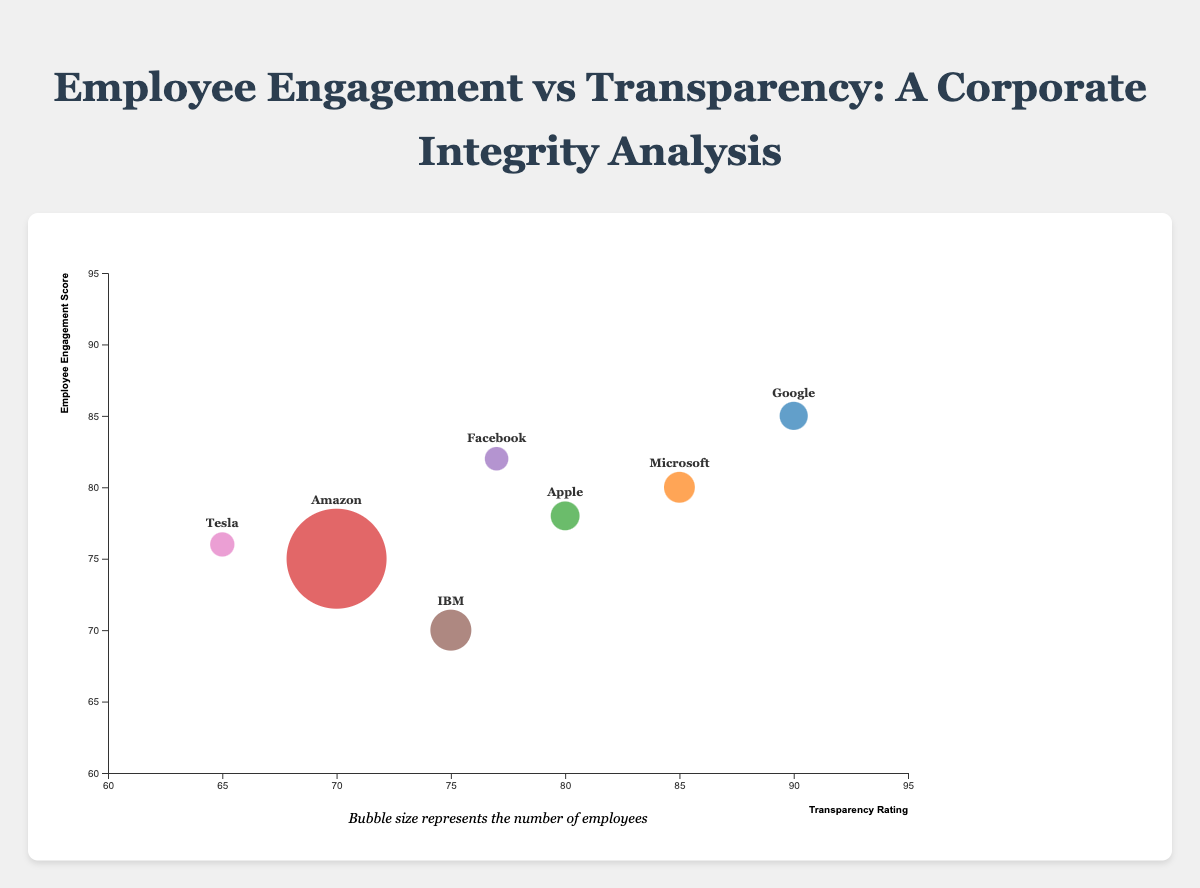What is the title of the Bubble Chart? The title is found at the top of the chart: "Employee Engagement vs Transparency: A Corporate Integrity Analysis." This text clearly describes the subject of the chart.
Answer: Employee Engagement vs Transparency: A Corporate Integrity Analysis How many firms are represented in this Bubble Chart? By counting the distinct bubbles on the chart and their corresponding labels, we can determine there are 7 firms included in the data.
Answer: 7 Which firm has the largest bubble in the chart, and what is its size representing? The largest bubble is for Amazon, as it visually stands out and is larger than others. The size of the bubble represents the number of employees, which for Amazon is 1,335,000.
Answer: Amazon (1,335,000 employees) Which firm has the highest employee engagement score, and what is the associated transparency rating? Google has the highest employee engagement score of 85. Looking at the coordinates, Google's transparency rating is 90.
Answer: Google (85 engagement, 90 transparency) What is the average transparency rating of all firms? Summing up the transparency ratings (90 + 85 + 80 + 70 + 77 + 75 + 65) gives 542. Dividing by the number of firms (7), we get an average transparency rating of 542/7 ≈ 77.43.
Answer: 77.43 Which firm in California has the highest employee engagement score? Three firms are located in California: Google, Apple, and Facebook. Google has the highest employee engagement score among them, which is 85.
Answer: Google Which firms have a transparency rating of at least 80? Looking at the x-axis, firms with a transparency rating of at least 80 include Google (90), Microsoft (85), Apple (80), and Facebook (77 is below the threshold).
Answer: Google, Microsoft, Apple What is the difference in employee engagement scores between the highest and lowest scoring firms? The highest engagement score is 85 (Google), and the lowest is 70 (IBM). The difference is 85 - 70 = 15.
Answer: 15 Which firm has the highest transparency rating but does not have the highest employee engagement score? Google has the highest transparency rating of 90, which is also the highest employee engagement score of 85. Therefore, the next highest rating of 85 is Microsoft, with an engagement score of 80, not the highest.
Answer: Microsoft What general trend can be observed between employee engagement scores and transparency ratings? By observing the distribution of the bubbles, there's a tendency for higher engagement scores to be associated with higher transparency ratings, which implies a positive correlation between these two metrics in the dataset.
Answer: Positive correlation 